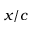<formula> <loc_0><loc_0><loc_500><loc_500>x / c</formula> 